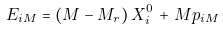<formula> <loc_0><loc_0><loc_500><loc_500>E _ { i M } = ( M - M _ { r } ) \, X _ { i } ^ { 0 } \, + \, M p _ { i M }</formula> 